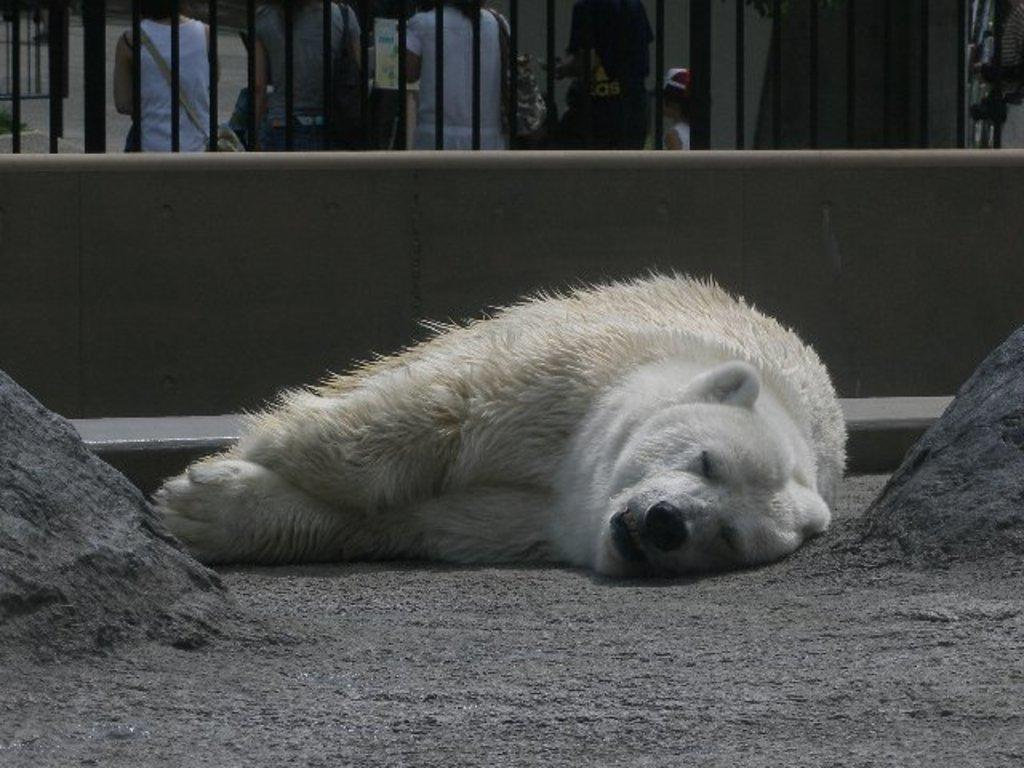What type of animal is in the image? There is a white color polar bear in the image. What is the polar bear doing in the image? The polar bear is sleeping on the land. What color is the railing in the image? The railing in the image is black. Can you describe the background of the image? There are people visible in the background of the image. What scientific effect can be observed in the image? There is no scientific effect present in the image; it features a polar bear sleeping on the land, a black railing, and people in the background. 